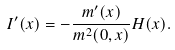<formula> <loc_0><loc_0><loc_500><loc_500>I ^ { \prime } ( x ) = - \frac { m ^ { \prime } ( x ) } { m ^ { 2 } ( 0 , x ) } H ( x ) .</formula> 